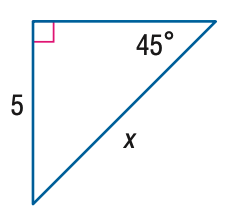Question: Find x.
Choices:
A. 5
B. 5 \sqrt { 2 }
C. 5 \sqrt { 3 }
D. 10
Answer with the letter. Answer: B 